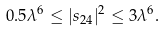<formula> <loc_0><loc_0><loc_500><loc_500>0 . 5 \lambda ^ { 6 } \leq | s _ { 2 4 } | ^ { 2 } \leq 3 \lambda ^ { 6 } .</formula> 